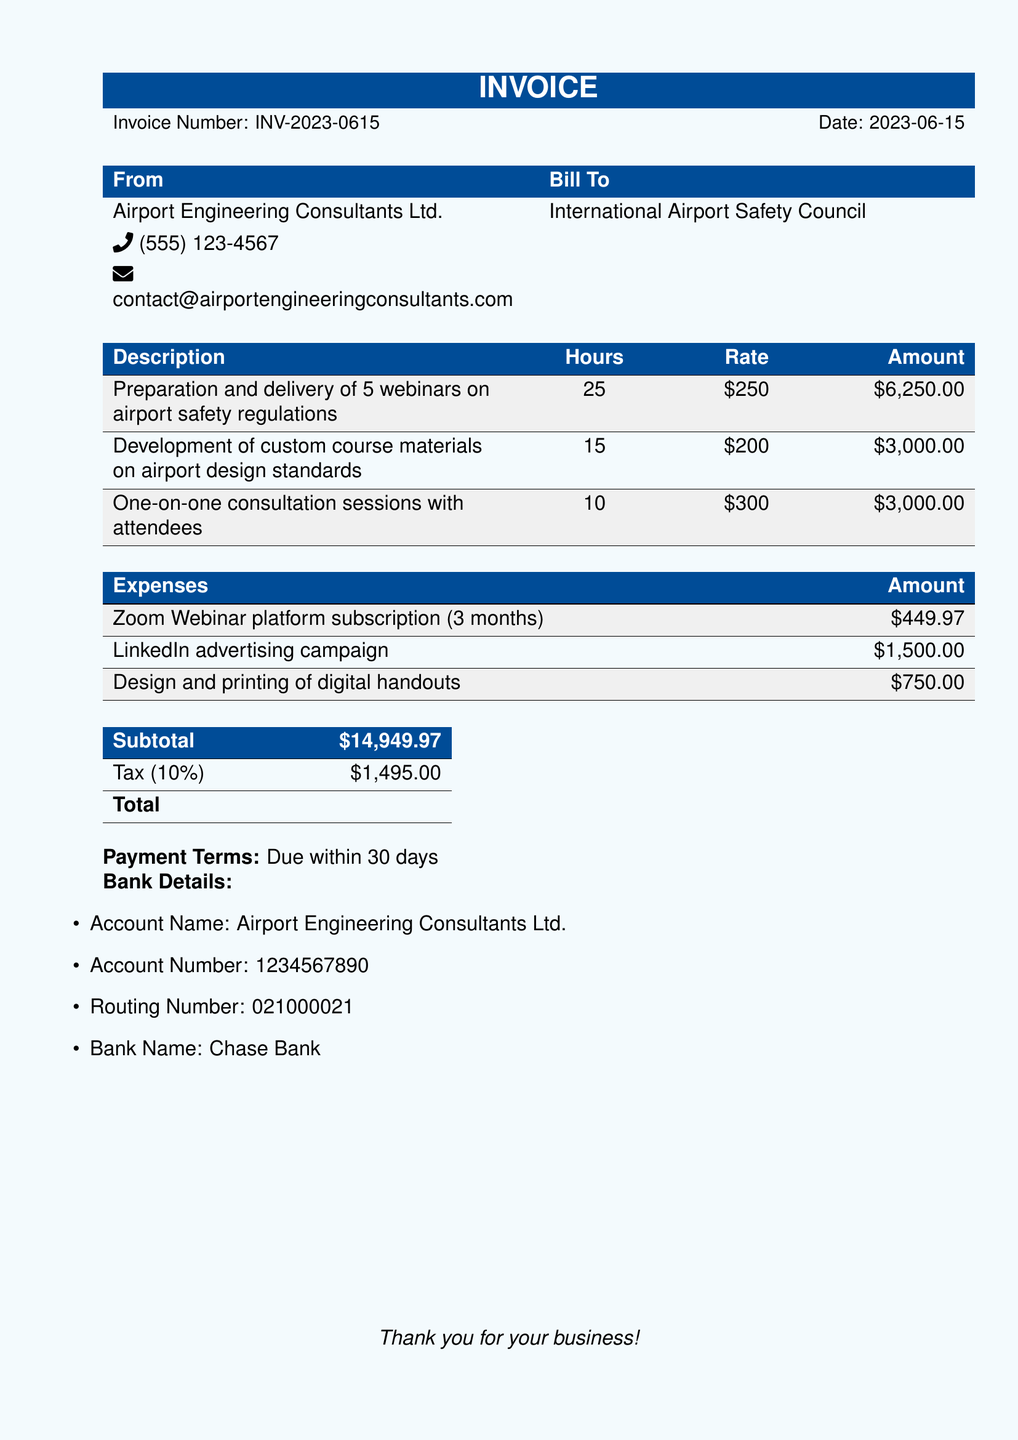What is the invoice number? The invoice number is listed at the top of the document as INV-2023-0615.
Answer: INV-2023-0615 What is the total amount due? The total amount due is found in the total section of the document, listed as \$16,444.97.
Answer: $16,444.97 How many webinars were prepared and delivered? The document states that 5 webinars on airport safety regulations were prepared and delivered.
Answer: 5 What is the fee for the one-on-one consultation sessions? The fee for one-on-one consultation sessions is detailed in the services section as $300 per hour.
Answer: $300 What is the tax percentage applied to the invoice? The tax is indicated as 10% in the totals section of the document.
Answer: 10% What are the payment terms? The payment terms are clearly stated as due within 30 days in the document.
Answer: Due within 30 days How much was spent on LinkedIn advertising? The document lists the amount spent on LinkedIn advertising as $1,500.00.
Answer: $1,500.00 Who is the billing recipient? The billing recipient is mentioned as the International Airport Safety Council.
Answer: International Airport Safety Council What is the subtotal amount before tax? The subtotal amount is provided in the document as $14,949.97.
Answer: $14,949.97 